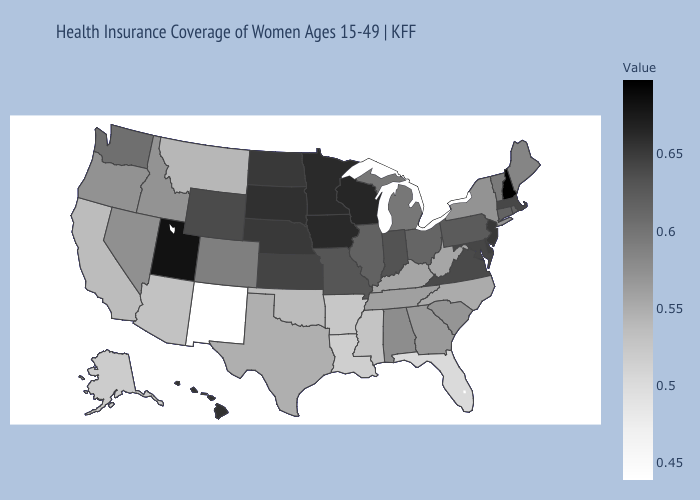Does Oklahoma have a lower value than New Mexico?
Write a very short answer. No. Does the map have missing data?
Give a very brief answer. No. Does New Hampshire have the highest value in the USA?
Concise answer only. Yes. Does New Mexico have the lowest value in the USA?
Short answer required. Yes. Does the map have missing data?
Answer briefly. No. Does California have a higher value than Florida?
Short answer required. Yes. 